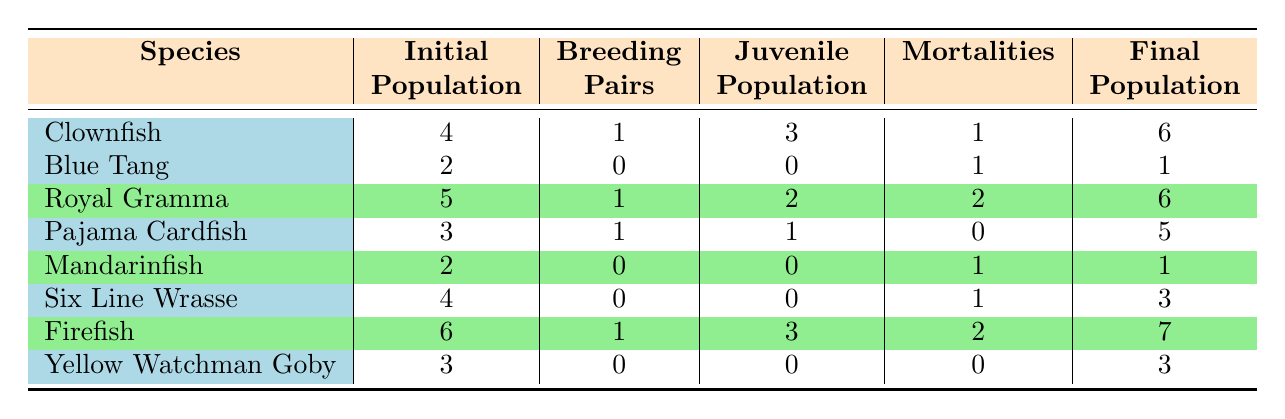What is the initial population of the Royal Gramma? The table shows that the Royal Gramma has an initial population listed in the second column. The value is 5.
Answer: 5 How many juvenile fish were produced by the Firefish? In the table, the Firefish has a juvenile population under the juvenile column. According to the data, it is 3.
Answer: 3 Did the Blue Tang have any breeding pairs? The Blue Tang's breeding pairs are recorded as 0 in the relevant column. This indicates there were no breeding pairs.
Answer: No Which species had the highest final population? By examining the final population column, we compare all the species: Clownfish has 6, Royal Gramma has 6, Pajama Cardfish has 5, Firefish has 7, and others have lower numbers. The Firefish has the highest at 7.
Answer: Firefish What is the total number of juveniles across all species? To find the total juveniles, we sum the juvenile populations: 3 (Clownfish) + 0 (Blue Tang) + 2 (Royal Gramma) + 1 (Pajama Cardfish) + 0 (Mandarinfish) + 0 (Six Line Wrasse) + 3 (Firefish) + 0 (Yellow Watchman Goby) = 9.
Answer: 9 Is it true that all species had mortalities in the setup? There are species which showed 0 mortalities, specifically the Pajama Cardfish and Yellow Watchman Goby. Thus, it is false that all had mortalities.
Answer: No What fish produced juvenile offspring and had a final population greater than the initial population? From the table, we check for breeding pairs and compare final vs initial populations. The Clownfish produced juveniles (3) and had a final population of 6 (greater than initial 4). The Royal Gramma also produced juveniles (2) and has a final population of 6 (greater than initial 5). The Firefish produced juveniles (3) and had a final population (7) greater than the initial (6). Therefore, Clownfish, Royal Gramma, and Firefish meet the criteria.
Answer: Clownfish, Royal Gramma, Firefish 